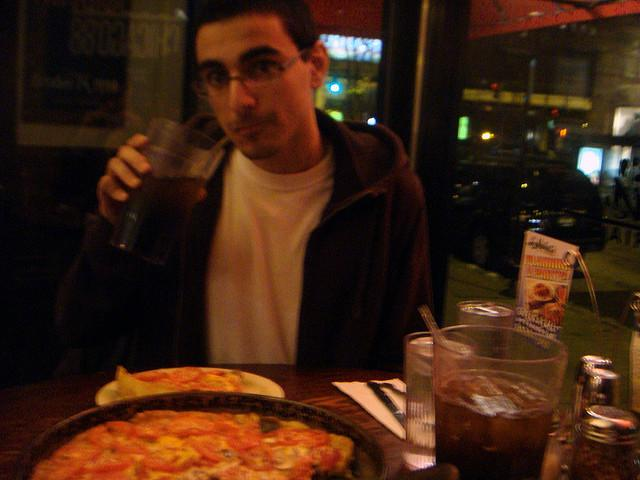What color is the soft drink drank by the man at the pizza store?

Choices:
A) clear
B) brown
C) blue
D) white brown 